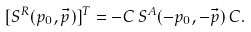<formula> <loc_0><loc_0><loc_500><loc_500>[ S ^ { R } ( p _ { 0 } , \vec { p } ) ] ^ { T } = - C \, S ^ { A } ( - p _ { 0 } , - \vec { p } ) \, C .</formula> 